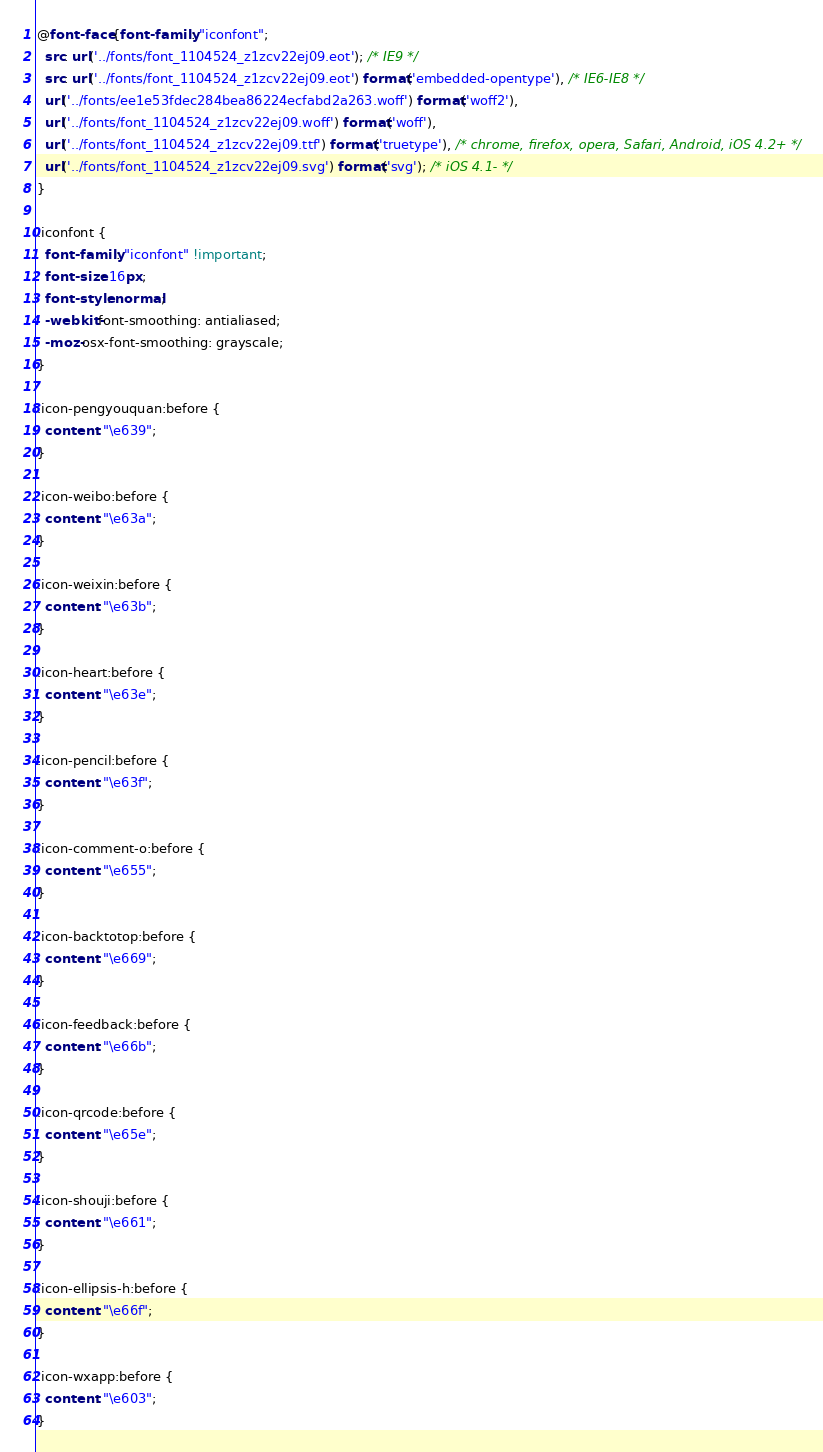Convert code to text. <code><loc_0><loc_0><loc_500><loc_500><_CSS_>@font-face {font-family: "iconfont";
  src: url('../fonts/font_1104524_z1zcv22ej09.eot'); /* IE9 */
  src: url('../fonts/font_1104524_z1zcv22ej09.eot') format('embedded-opentype'), /* IE6-IE8 */
  url('../fonts/ee1e53fdec284bea86224ecfabd2a263.woff') format('woff2'),
  url('../fonts/font_1104524_z1zcv22ej09.woff') format('woff'),
  url('../fonts/font_1104524_z1zcv22ej09.ttf') format('truetype'), /* chrome, firefox, opera, Safari, Android, iOS 4.2+ */
  url('../fonts/font_1104524_z1zcv22ej09.svg') format('svg'); /* iOS 4.1- */
}

.iconfont {
  font-family: "iconfont" !important;
  font-size: 16px;
  font-style: normal;
  -webkit-font-smoothing: antialiased;
  -moz-osx-font-smoothing: grayscale;
}

.icon-pengyouquan:before {
  content: "\e639";
}

.icon-weibo:before {
  content: "\e63a";
}

.icon-weixin:before {
  content: "\e63b";
}

.icon-heart:before {
  content: "\e63e";
}

.icon-pencil:before {
  content: "\e63f";
}

.icon-comment-o:before {
  content: "\e655";
}

.icon-backtotop:before {
  content: "\e669";
}

.icon-feedback:before {
  content: "\e66b";
}

.icon-qrcode:before {
  content: "\e65e";
}

.icon-shouji:before {
  content: "\e661";
}

.icon-ellipsis-h:before {
  content: "\e66f";
}

.icon-wxapp:before {
  content: "\e603";
}

</code> 